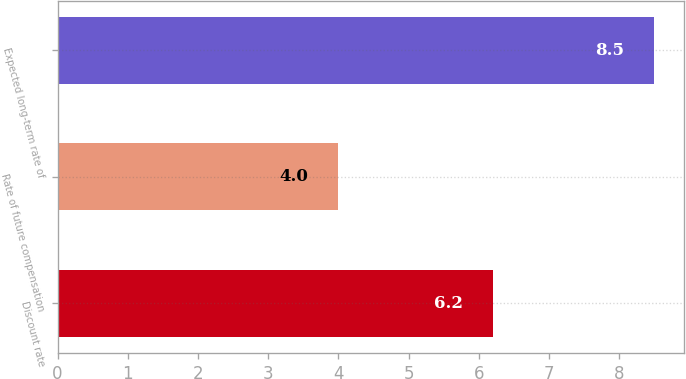<chart> <loc_0><loc_0><loc_500><loc_500><bar_chart><fcel>Discount rate<fcel>Rate of future compensation<fcel>Expected long-term rate of<nl><fcel>6.2<fcel>4<fcel>8.5<nl></chart> 